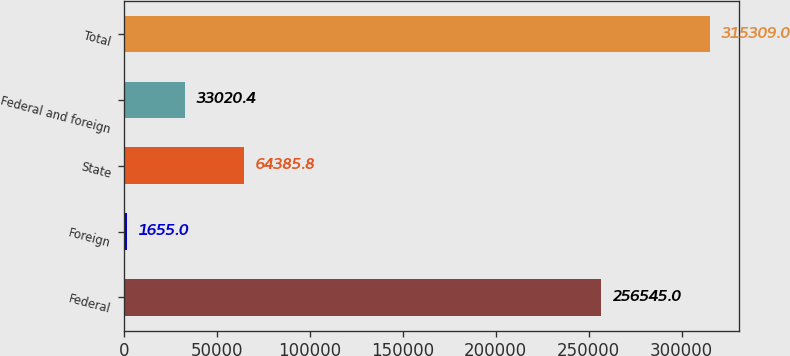Convert chart. <chart><loc_0><loc_0><loc_500><loc_500><bar_chart><fcel>Federal<fcel>Foreign<fcel>State<fcel>Federal and foreign<fcel>Total<nl><fcel>256545<fcel>1655<fcel>64385.8<fcel>33020.4<fcel>315309<nl></chart> 